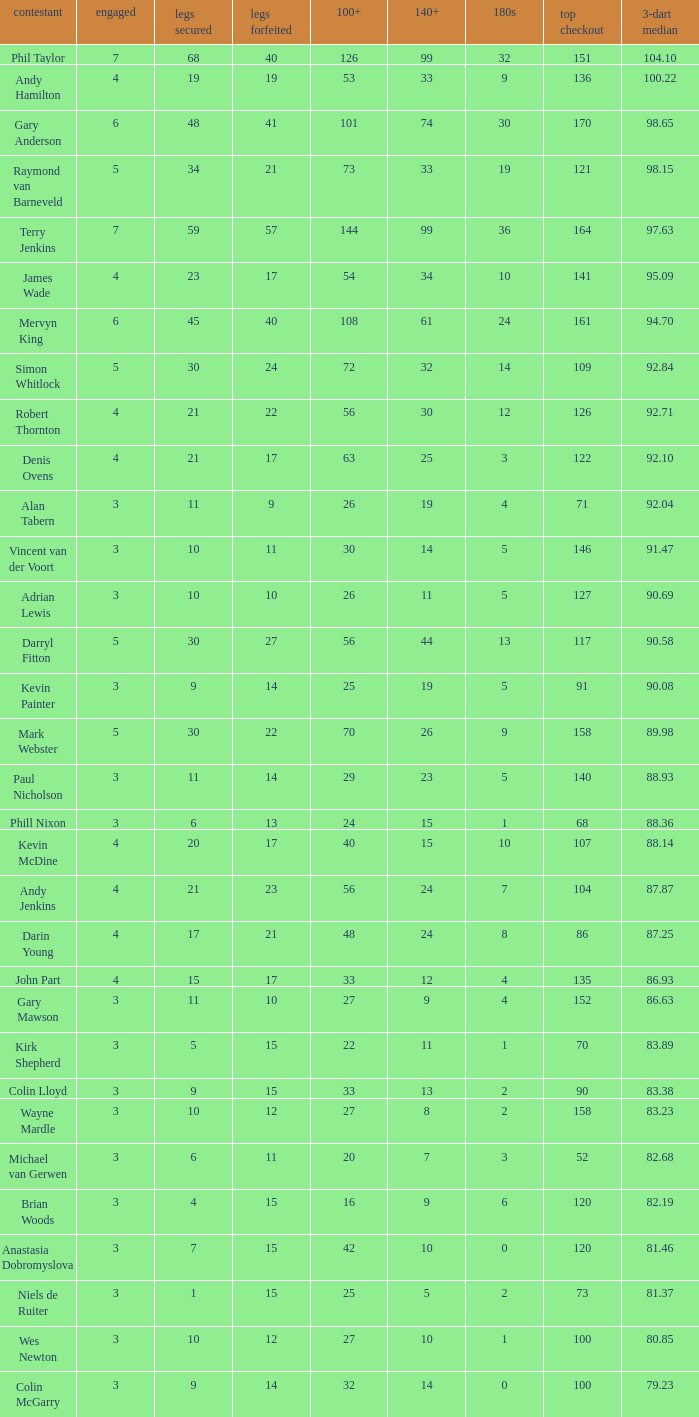What is the played number when the high checkout is 135? 4.0. 